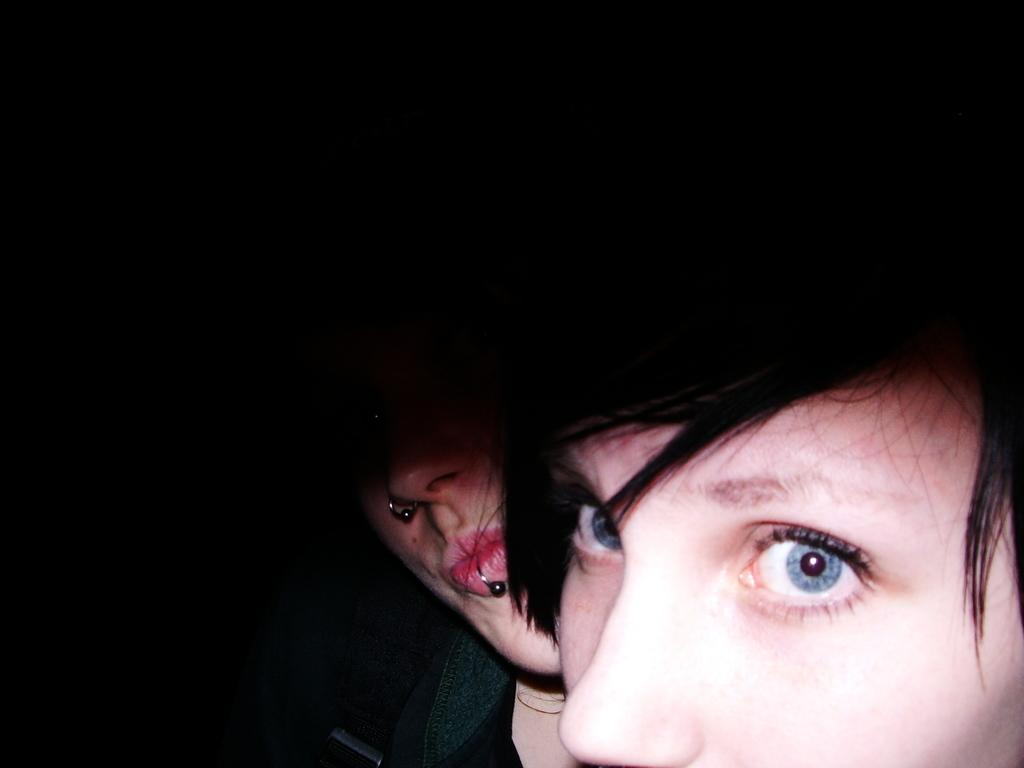How many faces can be seen in the image? There are two person faces in the image. What can be inferred about the lighting conditions in the image? The faces are in a dark environment. What type of beetle can be seen crawling on the person's face in the image? There is no beetle present on the person's face in the image. How does the earth's gravitational pull affect the person's faces in the image? The image does not provide any information about the earth's gravitational pull or its effect on the person's faces. 